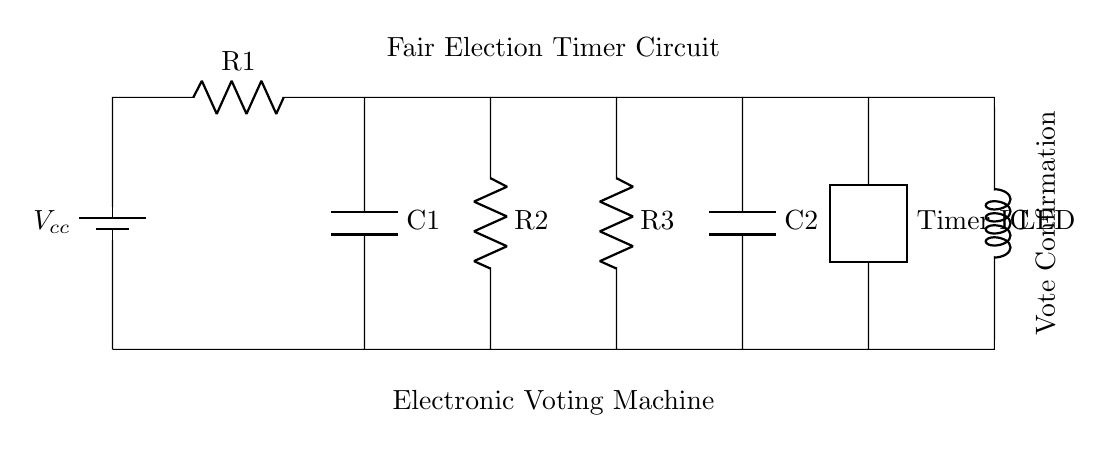What type of circuit is this? This circuit is a timer circuit, designed to manage delays and timing operations, with its components configured to create time delays indicative of an oscillator.
Answer: Timer circuit What components are present in this circuit? The circuit contains a battery, resistors (three in total), capacitors (two in total), a timer integrated circuit, and an LED for indication.
Answer: Battery, resistors, capacitors, Timer IC, LED How many resistors are in the circuit? By inspecting the circuit diagram, there are three indicated resistors connected between various components.
Answer: Three What is the function of the LED in this circuit? The LED acts as an indicator for vote confirmation, turning on when the timer circuit executes its function, signaling successful vote registration.
Answer: Vote confirmation What is connected to the output of the Timer IC? The LED is directly connected to the output of the Timer integrated circuit, which provides the signal to power the LED based on the timer settings.
Answer: LED How do the resistors affect the timer operation? The resistors impact the timing characteristics by controlling the charging and discharging of the capacitors, thus altering the timing interval of the oscillator's output.
Answer: Control timing What role do capacitors play in this circuit? Capacitors store charge and release it, which is essential for generating time delays in the timer circuit, directly affecting its oscillation frequency and duty cycle.
Answer: Generate time delays 